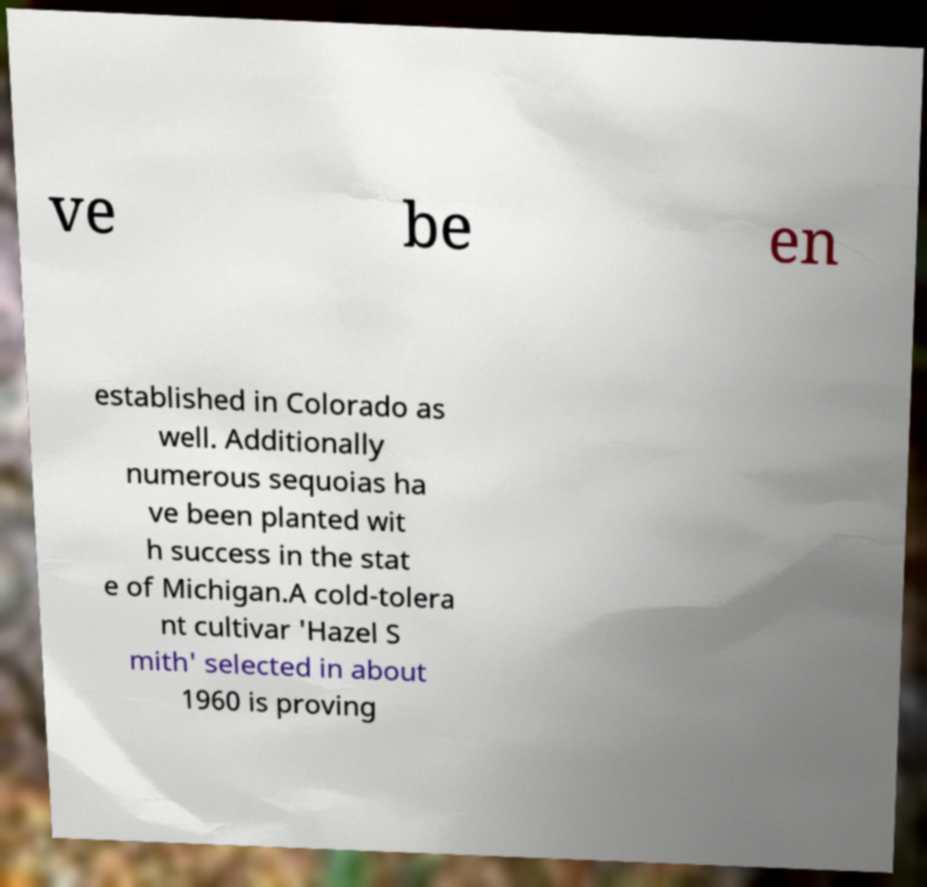There's text embedded in this image that I need extracted. Can you transcribe it verbatim? ve be en established in Colorado as well. Additionally numerous sequoias ha ve been planted wit h success in the stat e of Michigan.A cold-tolera nt cultivar 'Hazel S mith' selected in about 1960 is proving 